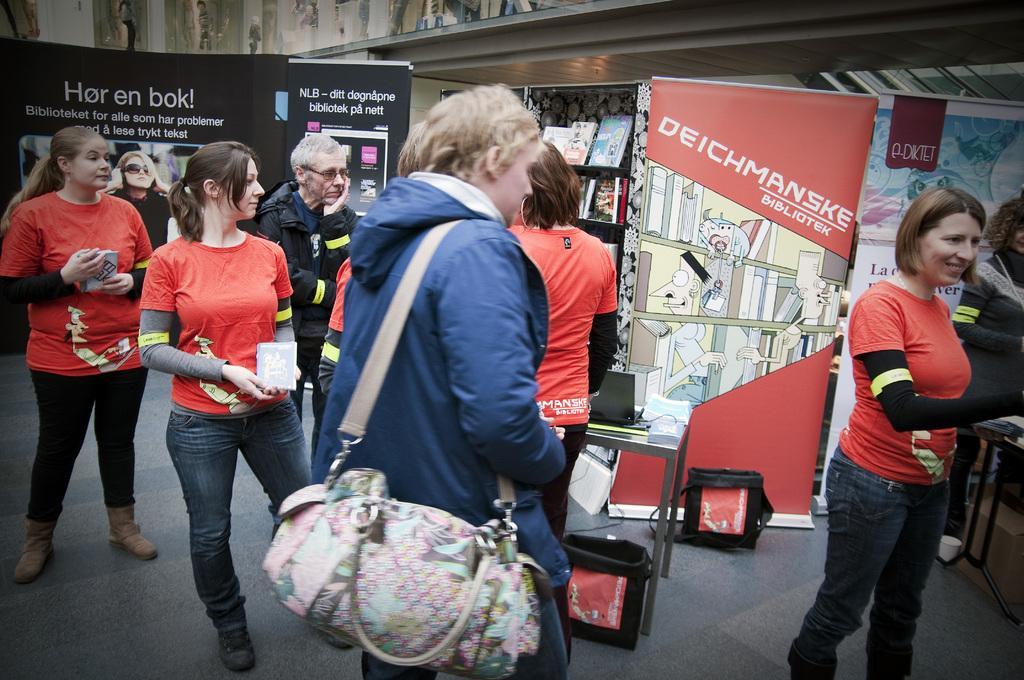Describe this image in one or two sentences. This is the picture taken in the outdoor, there are group of people in red t shirt are standing on the floor. The man in blue jacket holding a bag and background of this people is a banners which is in red and black color and there is a shelf background of this people on the shelf there are the books. 